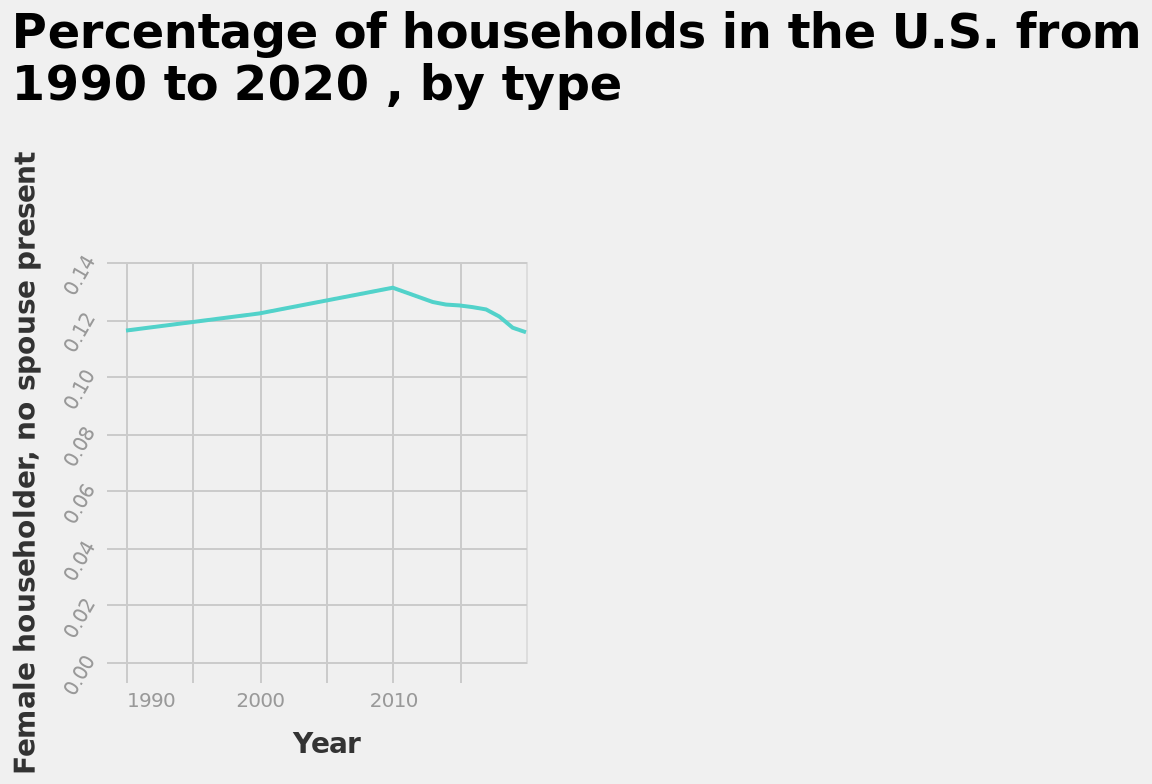<image>
What is the range of the y-axis? The range of the y-axis is from 0.00 to 0.14. What is the trend shown on the chart from 1990 to 2010?  The trend on the chart from 1990 to 2010 shows a slowly rising increase. What is the label on the y-axis? The y-axis is labeled "Female householder, no spouse present." When does the trajectory on the chart reach its peak? The trajectory on the chart reaches its peak in 2010. Does the trajectory on the chart reach its peak in 2005? No.The trajectory on the chart reaches its peak in 2010. 